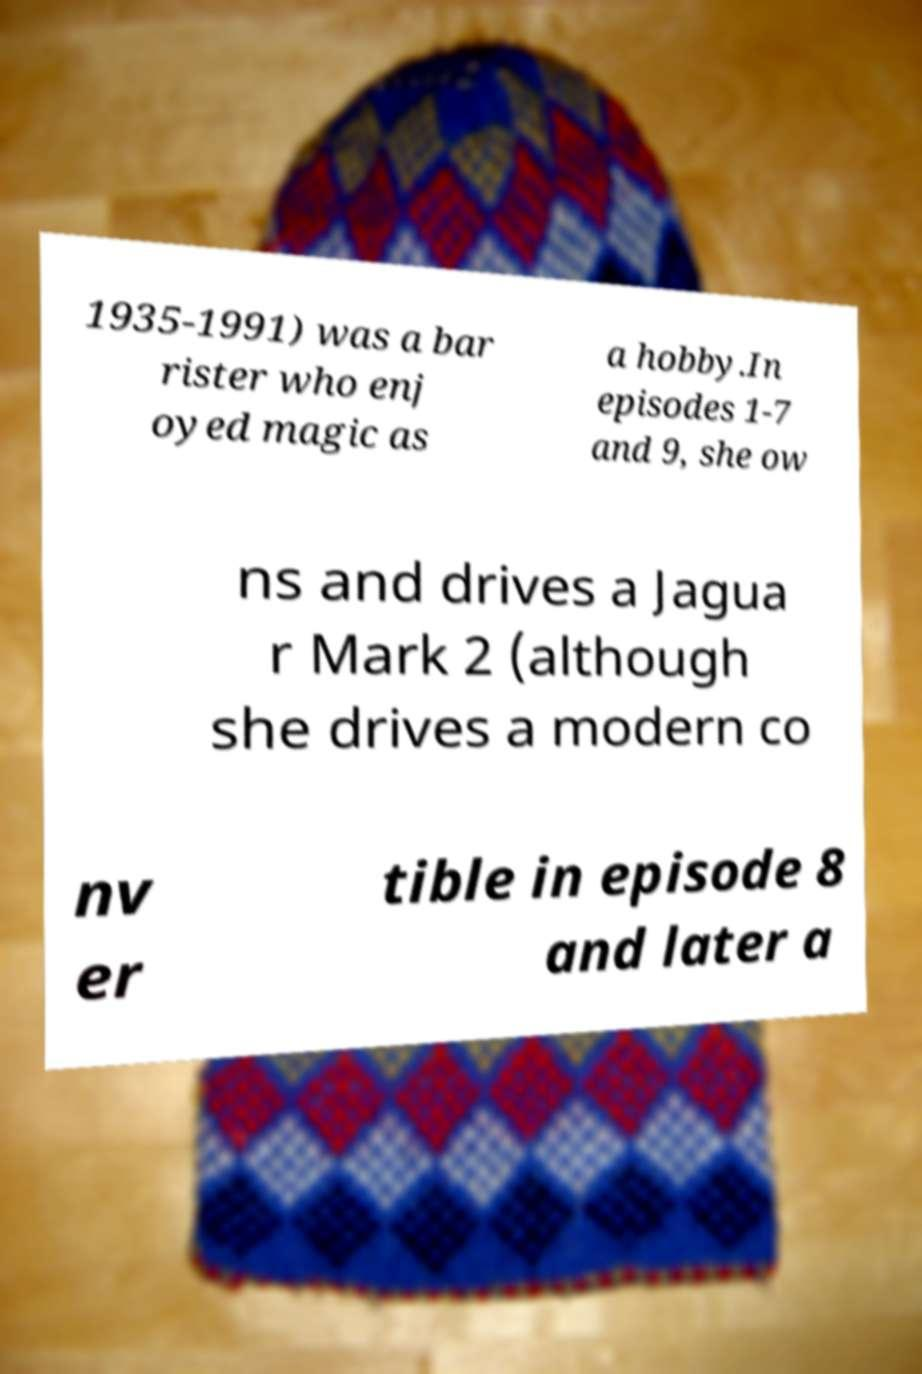Can you read and provide the text displayed in the image?This photo seems to have some interesting text. Can you extract and type it out for me? 1935-1991) was a bar rister who enj oyed magic as a hobby.In episodes 1-7 and 9, she ow ns and drives a Jagua r Mark 2 (although she drives a modern co nv er tible in episode 8 and later a 